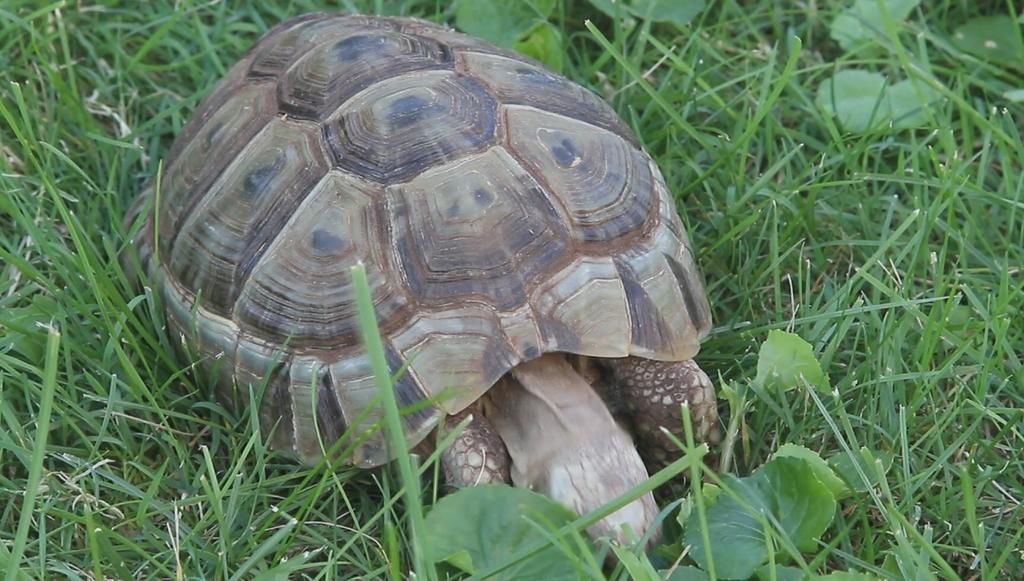Describe this image in one or two sentences. In this image I can see a tortoise on the ground. Around this I can see the grass and few plants. 